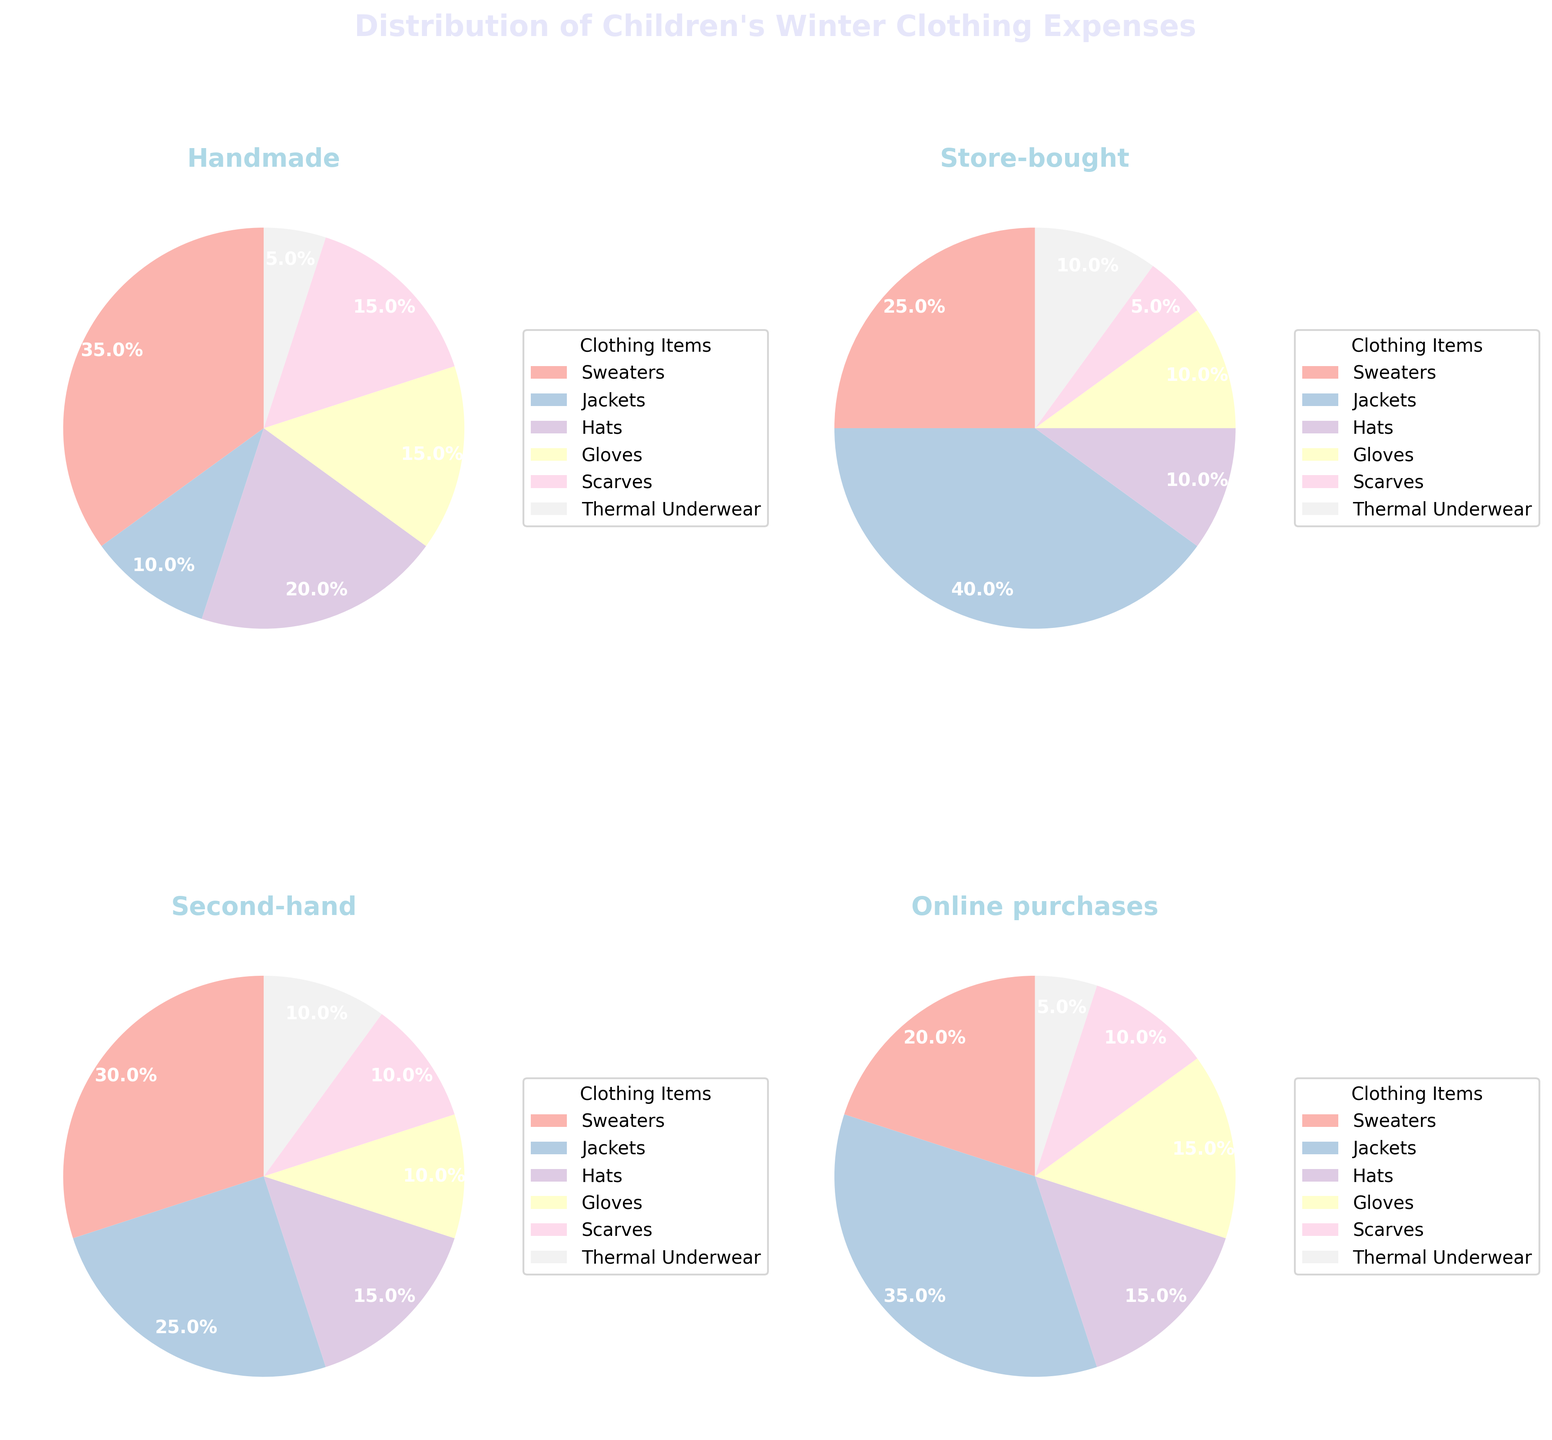What is the title of the figure? The title is usually located at the top of the figure. Here, the title "Distribution of Children's Winter Clothing Expenses" is prominently displayed there.
Answer: Distribution of Children's Winter Clothing Expenses Which category shows the largest expense on jackets? By examining each pie chart, you can see that the "Store-bought" category has the highest segment dedicated to jackets.
Answer: Store-bought How does the percentage spent on gloves compare between "Handmade" and "Online purchases"? The "Handmade" pie chart shows 15% spent on gloves, while "Online purchases" also show 15%. Both sections are equal in size and percentage.
Answer: Equal Which category spends the least on thermal underwear? By looking at the smallest segments for thermal underwear in each pie chart, "Handmade" has a 5% allocation, which is the smallest compared to other categories.
Answer: Handmade What is the combined percentage of expenses on hats and scarves in the "Second-hand" category? The percentage of expenses on hats is 15%, and on scarves is 10%. Adding these percentages together gives 15% + 10% = 25%.
Answer: 25% How much more is spent on jackets in the "Online purchases" category compared to the "Handmade" category? The "Online purchases" category spends 35% on jackets, whereas the "Handmade" category spends 10%. The difference is therefore 35% - 10% = 25%.
Answer: 25% What is the ratio of expenses on sweaters to gloves in the "Handmade" category? In the "Handmade" category, 35% is spent on sweaters and 15% on gloves. The ratio can be calculated as 35:15, which simplifies to 7:3.
Answer: 7:3 Among all categories, which one allocates the highest percentage to sweaters? By looking for the largest segment representing sweaters in all pie charts, you find that "Handmade" allocates 35% to sweaters, which is the highest.
Answer: Handmade Is the percentage spent on hats greater in the "Second-hand" category compared to the "Store-bought" category? The "Second-hand" category spends 15% on hats, while the "Store-bought" category spends 10%. Hence, the percentage is indeed greater in the "Second-hand" category.
Answer: Yes 